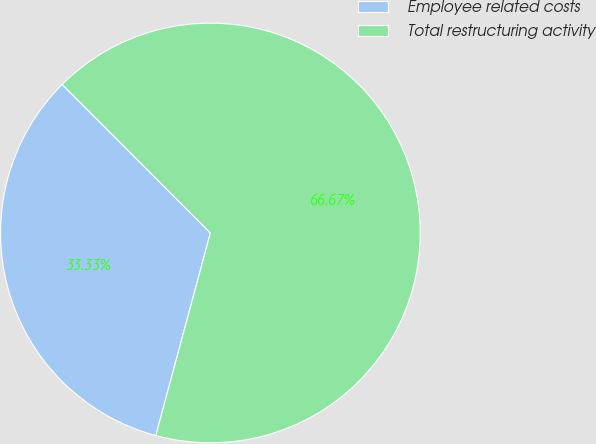Convert chart. <chart><loc_0><loc_0><loc_500><loc_500><pie_chart><fcel>Employee related costs<fcel>Total restructuring activity<nl><fcel>33.33%<fcel>66.67%<nl></chart> 